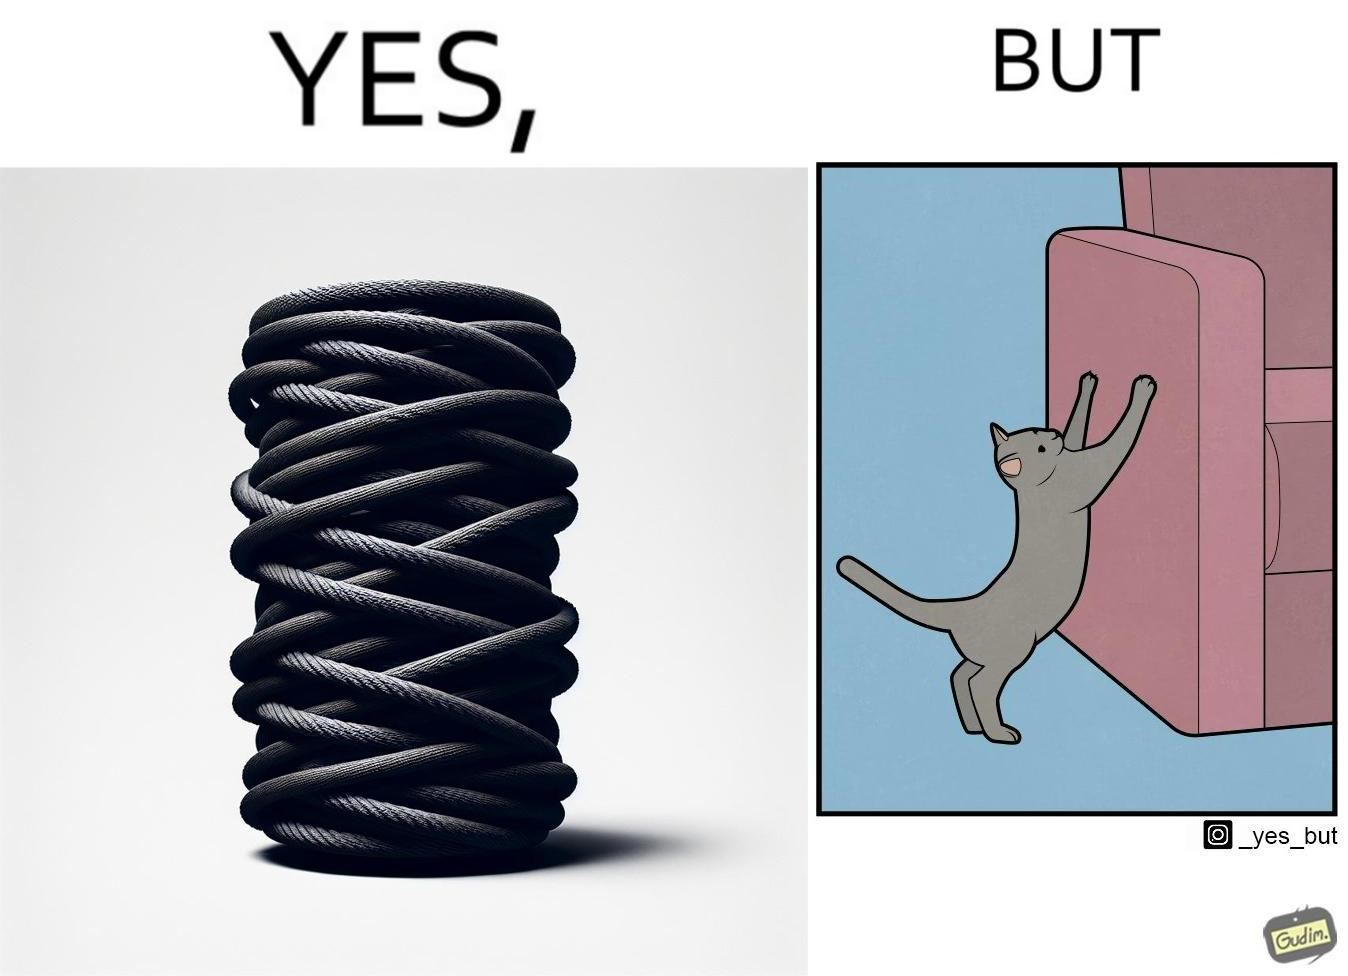Why is this image considered satirical? The image is ironic, because in the first image a toy, purposed for the cat to play with is shown but in the second image the cat is comfortably enjoying  to play on the sides of sofa 